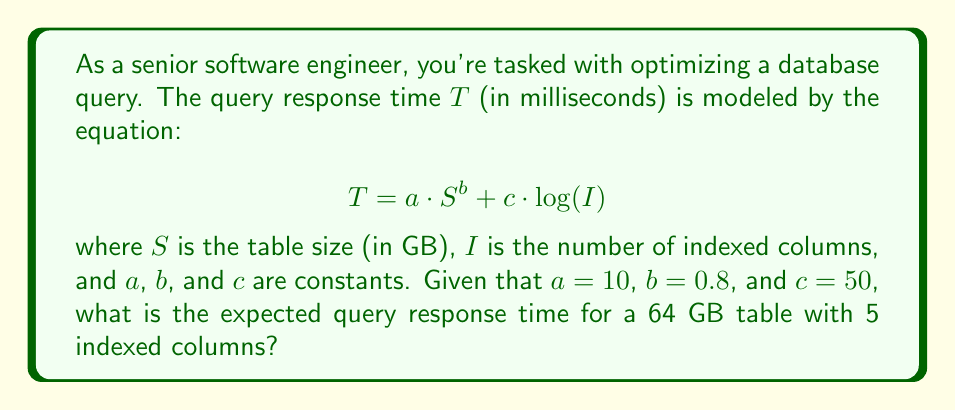Can you solve this math problem? To solve this problem, we'll follow these steps:

1. Identify the given values:
   $a = 10$
   $b = 0.8$
   $c = 50$
   $S = 64$ GB
   $I = 5$ indexed columns

2. Substitute these values into the equation:
   $$T = 10 \cdot 64^{0.8} + 50 \cdot \log(5)$$

3. Calculate $64^{0.8}$:
   $$64^{0.8} = 2^{6 \cdot 0.8} = 2^{4.8} \approx 27.8576$$

4. Calculate $\log(5)$:
   $$\log(5) \approx 1.6094$$

5. Multiply the results:
   $$10 \cdot 27.8576 \approx 278.576$$
   $$50 \cdot 1.6094 \approx 80.47$$

6. Sum up the two parts:
   $$278.576 + 80.47 \approx 359.046$$

7. Round to the nearest millisecond:
   $$T \approx 359 \text{ ms}$$
Answer: 359 ms 